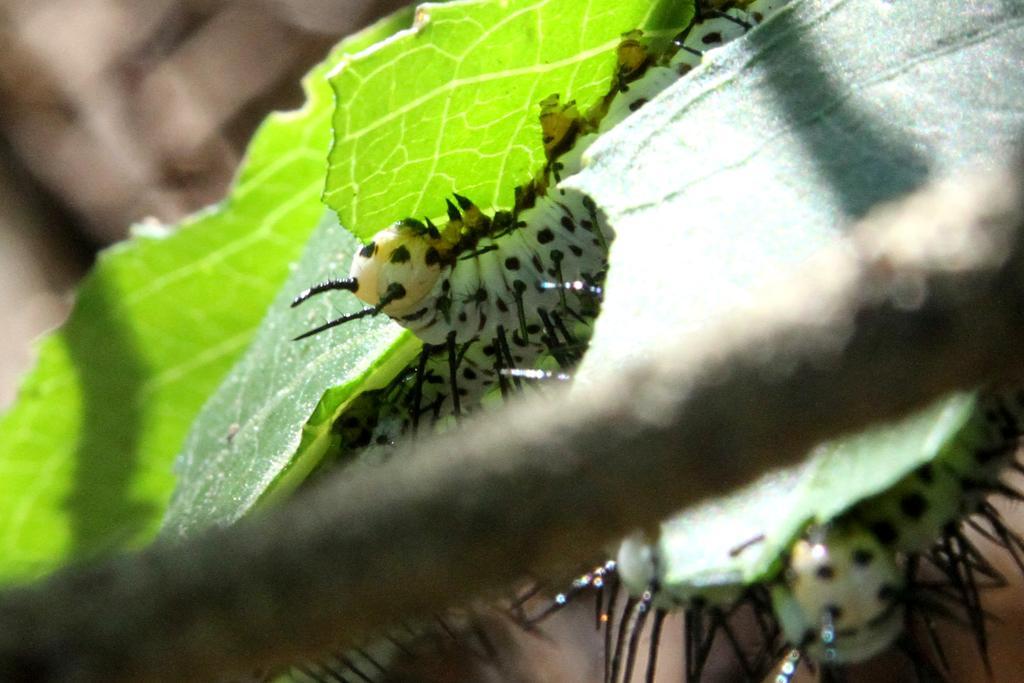In one or two sentences, can you explain what this image depicts? In this image we can see insects on the leaves, and the background is blurred. 